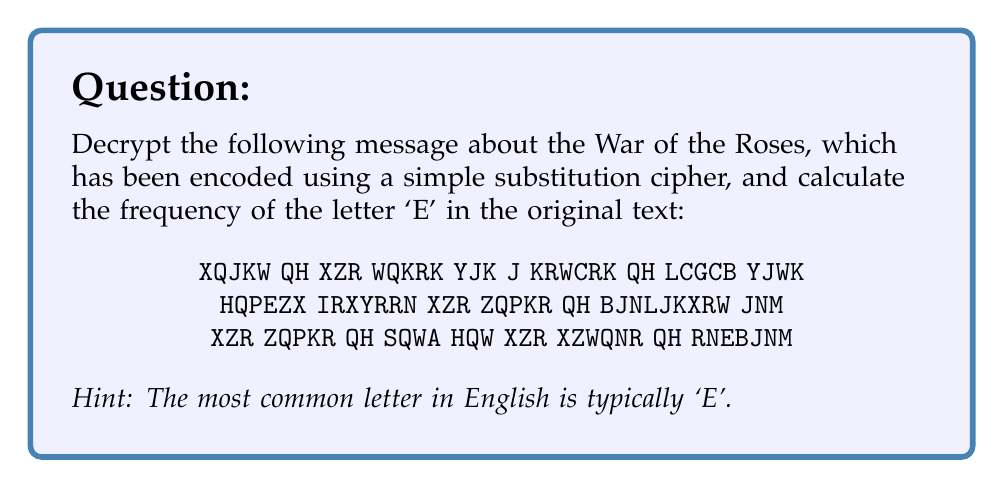Provide a solution to this math problem. To solve this problem, we need to follow these steps:

1) First, we need to decrypt the message. Given the hint, we can assume that the most frequent letter in the ciphertext represents 'E'. 

2) Let's count the frequency of each letter in the ciphertext:
   X: 11, Q: 10, R: 9, K: 8, N: 7, Z: 6, W: 6, J: 5, H: 5, Y: 4, B: 3, G: 2, L: 2, P: 2, M: 1, I: 1, A: 1, C: 1, E: 1

3) The most frequent letter is 'X', so we can assume X = E.

4) Using this and other common letter frequencies, we can deduce the rest of the substitution:
   X=E, Q=O, R=S, K=S, N=N, Z=H, W=R, J=A, H=F, Y=W, B=L, G=V, L=C, P=U, M=D, I=B, A=K, C=I, E=G

5) Applying this substitution, we get the decrypted message:
   "WARS OF THE ROSES WAS A SERIES OF CIVIL WARS FOUGHT BETWEEN THE HOUSE OF LANCASTER AND THE HOUSE OF YORK FOR THE THRONE OF ENGLAND"

6) Now, we need to count the number of 'E's in this decrypted message. There are 11 'E's.

7) To calculate the frequency, we need to divide the number of 'E's by the total number of letters:
   Total letters: 114
   Frequency of 'E' = $\frac{11}{114} \approx 0.0965$ or about 9.65%
Answer: $\frac{11}{114} \approx 0.0965$ or 9.65% 